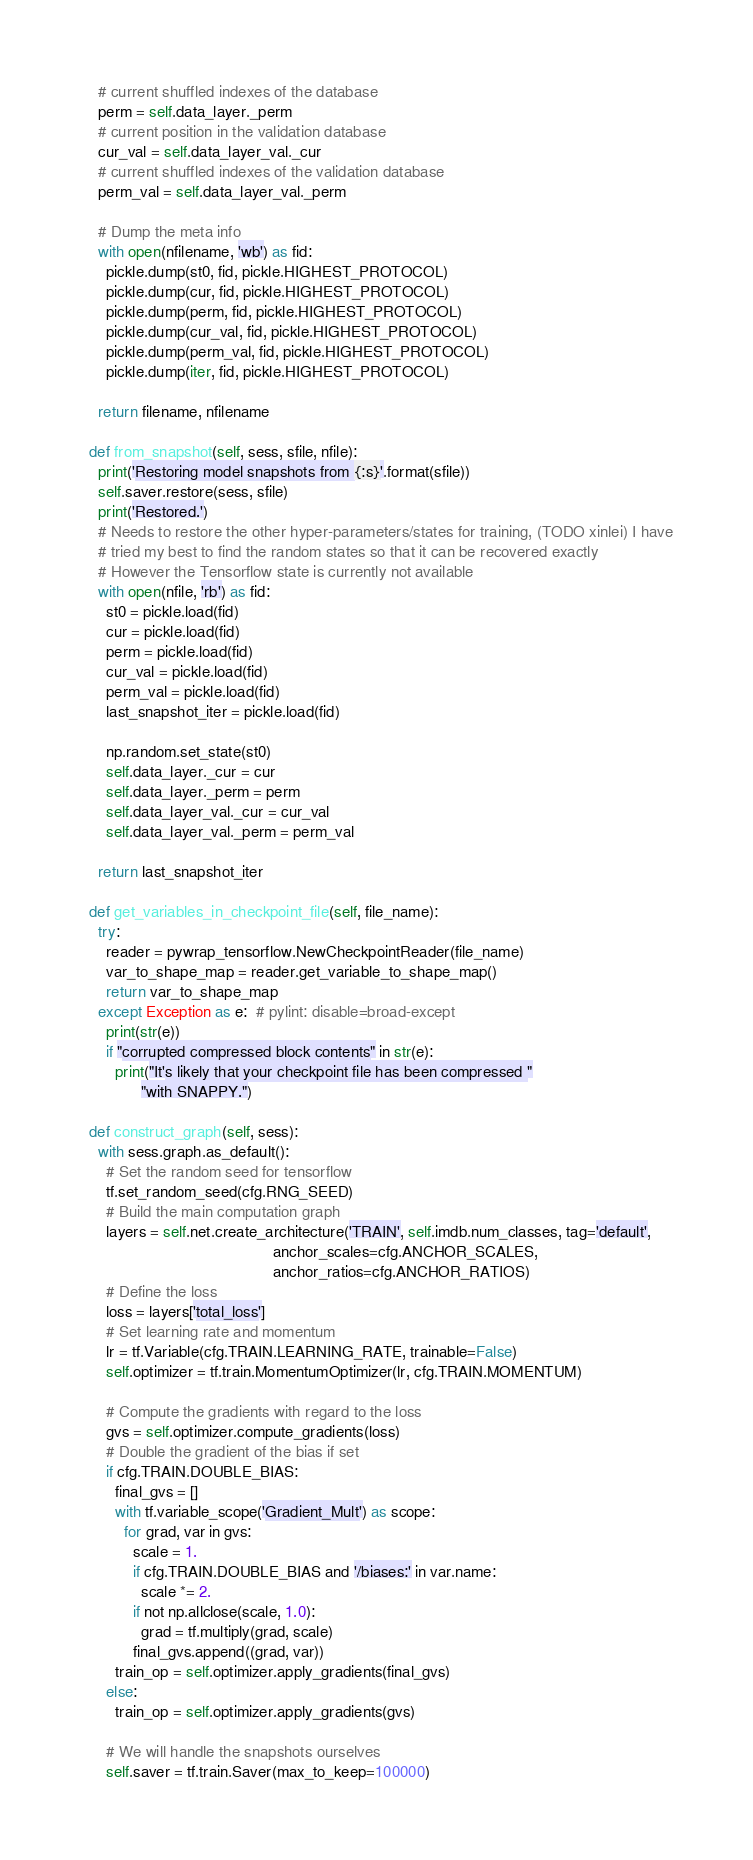Convert code to text. <code><loc_0><loc_0><loc_500><loc_500><_Python_>    # current shuffled indexes of the database
    perm = self.data_layer._perm
    # current position in the validation database
    cur_val = self.data_layer_val._cur
    # current shuffled indexes of the validation database
    perm_val = self.data_layer_val._perm

    # Dump the meta info
    with open(nfilename, 'wb') as fid:
      pickle.dump(st0, fid, pickle.HIGHEST_PROTOCOL)
      pickle.dump(cur, fid, pickle.HIGHEST_PROTOCOL)
      pickle.dump(perm, fid, pickle.HIGHEST_PROTOCOL)
      pickle.dump(cur_val, fid, pickle.HIGHEST_PROTOCOL)
      pickle.dump(perm_val, fid, pickle.HIGHEST_PROTOCOL)
      pickle.dump(iter, fid, pickle.HIGHEST_PROTOCOL)

    return filename, nfilename

  def from_snapshot(self, sess, sfile, nfile):
    print('Restoring model snapshots from {:s}'.format(sfile))
    self.saver.restore(sess, sfile)
    print('Restored.')
    # Needs to restore the other hyper-parameters/states for training, (TODO xinlei) I have
    # tried my best to find the random states so that it can be recovered exactly
    # However the Tensorflow state is currently not available
    with open(nfile, 'rb') as fid:
      st0 = pickle.load(fid)
      cur = pickle.load(fid)
      perm = pickle.load(fid)
      cur_val = pickle.load(fid)
      perm_val = pickle.load(fid)
      last_snapshot_iter = pickle.load(fid)

      np.random.set_state(st0)
      self.data_layer._cur = cur
      self.data_layer._perm = perm
      self.data_layer_val._cur = cur_val
      self.data_layer_val._perm = perm_val

    return last_snapshot_iter

  def get_variables_in_checkpoint_file(self, file_name):
    try:
      reader = pywrap_tensorflow.NewCheckpointReader(file_name)
      var_to_shape_map = reader.get_variable_to_shape_map()
      return var_to_shape_map 
    except Exception as e:  # pylint: disable=broad-except
      print(str(e))
      if "corrupted compressed block contents" in str(e):
        print("It's likely that your checkpoint file has been compressed "
              "with SNAPPY.")

  def construct_graph(self, sess):
    with sess.graph.as_default():
      # Set the random seed for tensorflow
      tf.set_random_seed(cfg.RNG_SEED)
      # Build the main computation graph
      layers = self.net.create_architecture('TRAIN', self.imdb.num_classes, tag='default',
                                            anchor_scales=cfg.ANCHOR_SCALES,
                                            anchor_ratios=cfg.ANCHOR_RATIOS)
      # Define the loss
      loss = layers['total_loss']
      # Set learning rate and momentum
      lr = tf.Variable(cfg.TRAIN.LEARNING_RATE, trainable=False)
      self.optimizer = tf.train.MomentumOptimizer(lr, cfg.TRAIN.MOMENTUM)

      # Compute the gradients with regard to the loss
      gvs = self.optimizer.compute_gradients(loss)
      # Double the gradient of the bias if set
      if cfg.TRAIN.DOUBLE_BIAS:
        final_gvs = []
        with tf.variable_scope('Gradient_Mult') as scope:
          for grad, var in gvs:
            scale = 1.
            if cfg.TRAIN.DOUBLE_BIAS and '/biases:' in var.name:
              scale *= 2.
            if not np.allclose(scale, 1.0):
              grad = tf.multiply(grad, scale)
            final_gvs.append((grad, var))
        train_op = self.optimizer.apply_gradients(final_gvs)
      else:
        train_op = self.optimizer.apply_gradients(gvs)

      # We will handle the snapshots ourselves
      self.saver = tf.train.Saver(max_to_keep=100000)</code> 